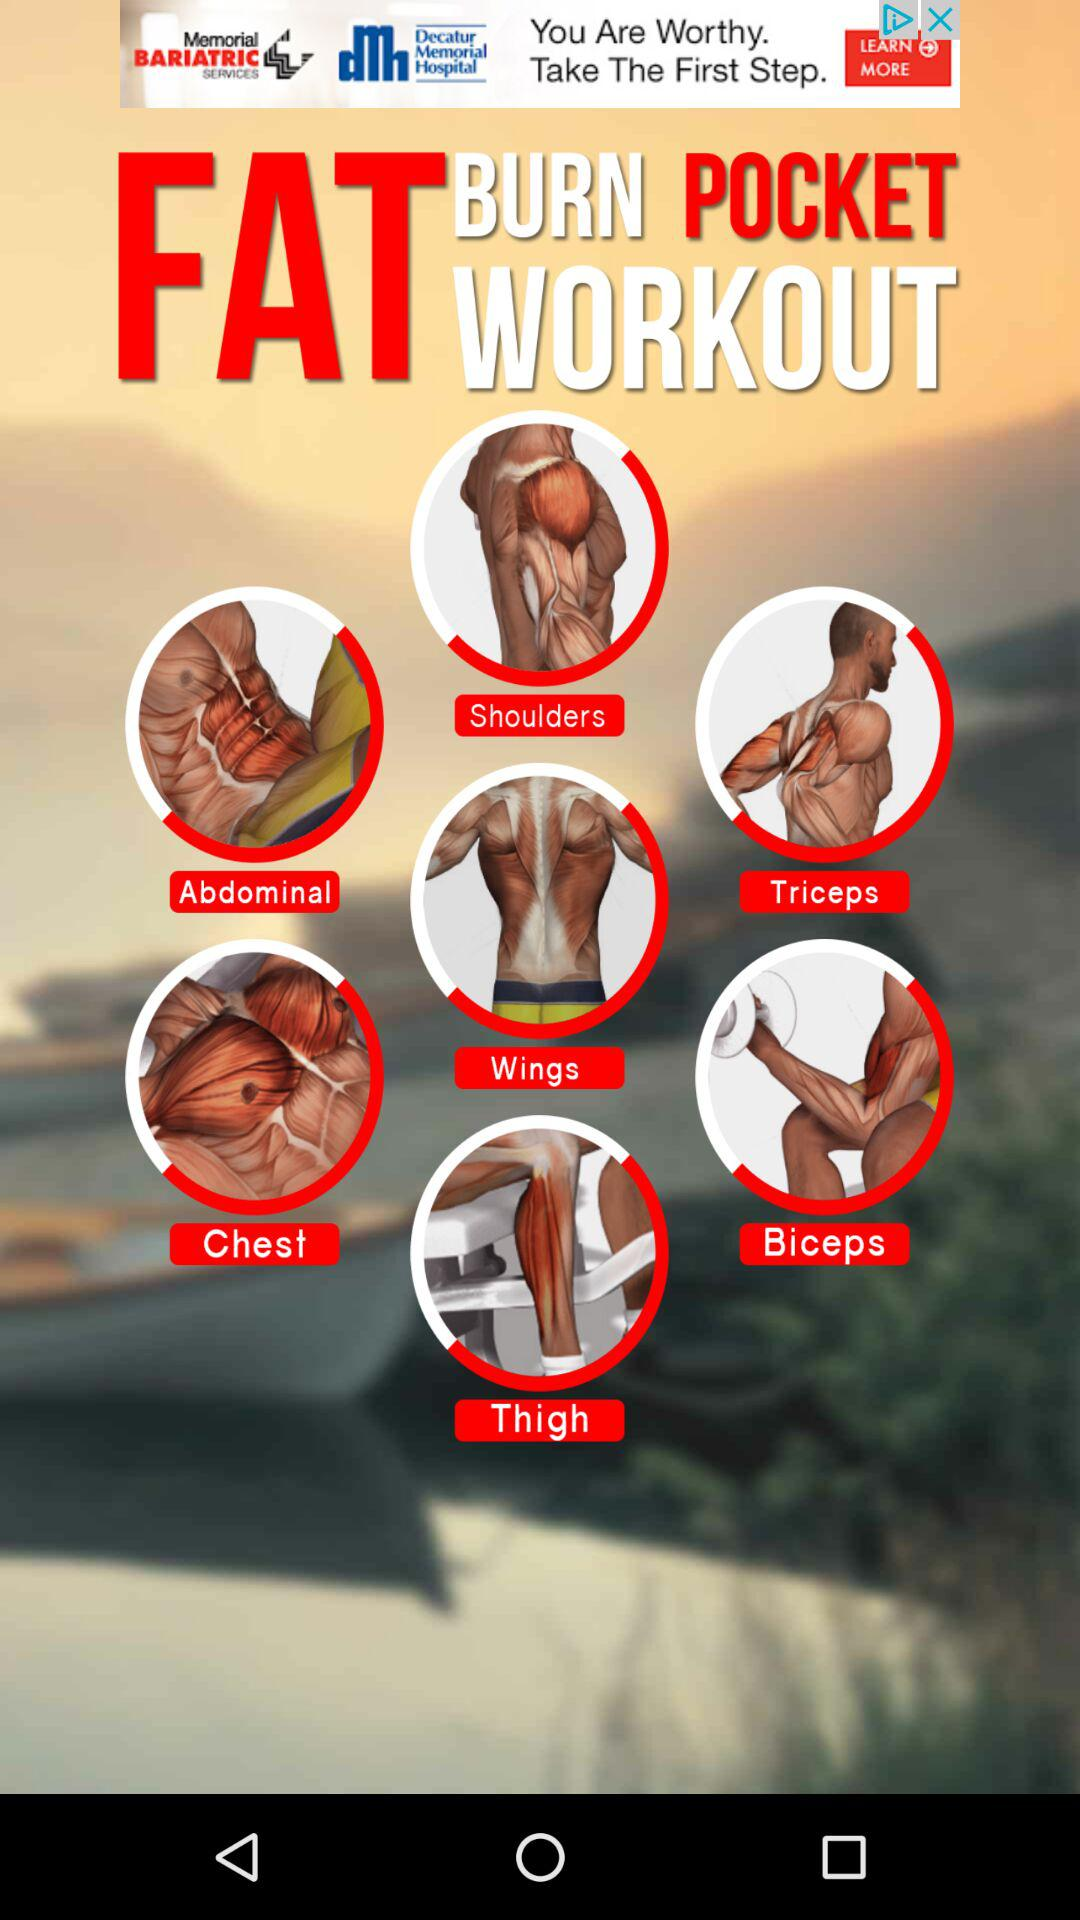What are the different types of fat-burning pocket workout? The different types of fat-burning pocket workouts are "Shoulders", "Abdominal", "Triceps", "Wings", "Chest", "Biceps" and "Thigh". 